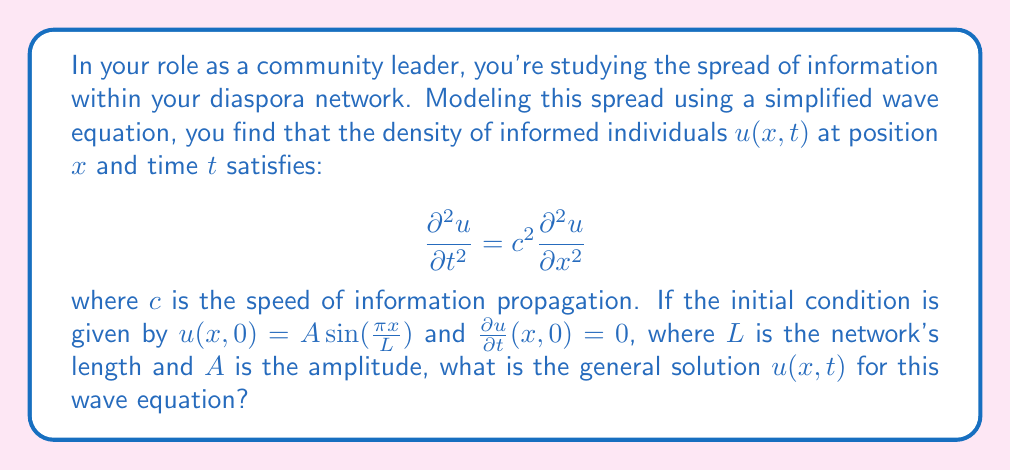Teach me how to tackle this problem. To solve this wave equation, we'll follow these steps:

1) The general solution for a wave equation with the given initial conditions is of the form:

   $$u(x,t) = F(x-ct) + G(x+ct)$$

2) Given the initial condition $u(x,0) = A \sin(\frac{\pi x}{L})$, we can deduce:

   $$F(x) + G(x) = A \sin(\frac{\pi x}{L})$$

3) The second initial condition $\frac{\partial u}{\partial t}(x,0) = 0$ implies:

   $$-cF'(x) + cG'(x) = 0$$

   This means $F'(x) = G'(x)$, so $F(x) = G(x) + \text{constant}$

4) From steps 2 and 3, we can conclude:

   $$F(x) = G(x) = \frac{1}{2}A \sin(\frac{\pi x}{L})$$

5) Substituting these back into the general solution:

   $$u(x,t) = \frac{1}{2}A \sin(\frac{\pi (x-ct)}{L}) + \frac{1}{2}A \sin(\frac{\pi (x+ct)}{L})$$

6) Using the trigonometric identity for the sum of sines:

   $$\sin A + \sin B = 2 \sin(\frac{A+B}{2}) \cos(\frac{A-B}{2})$$

7) We get the final solution:

   $$u(x,t) = A \sin(\frac{\pi x}{L}) \cos(\frac{\pi ct}{L})$$

This solution represents a standing wave in the social network, where information oscillates in place rather than propagating.
Answer: $u(x,t) = A \sin(\frac{\pi x}{L}) \cos(\frac{\pi ct}{L})$ 